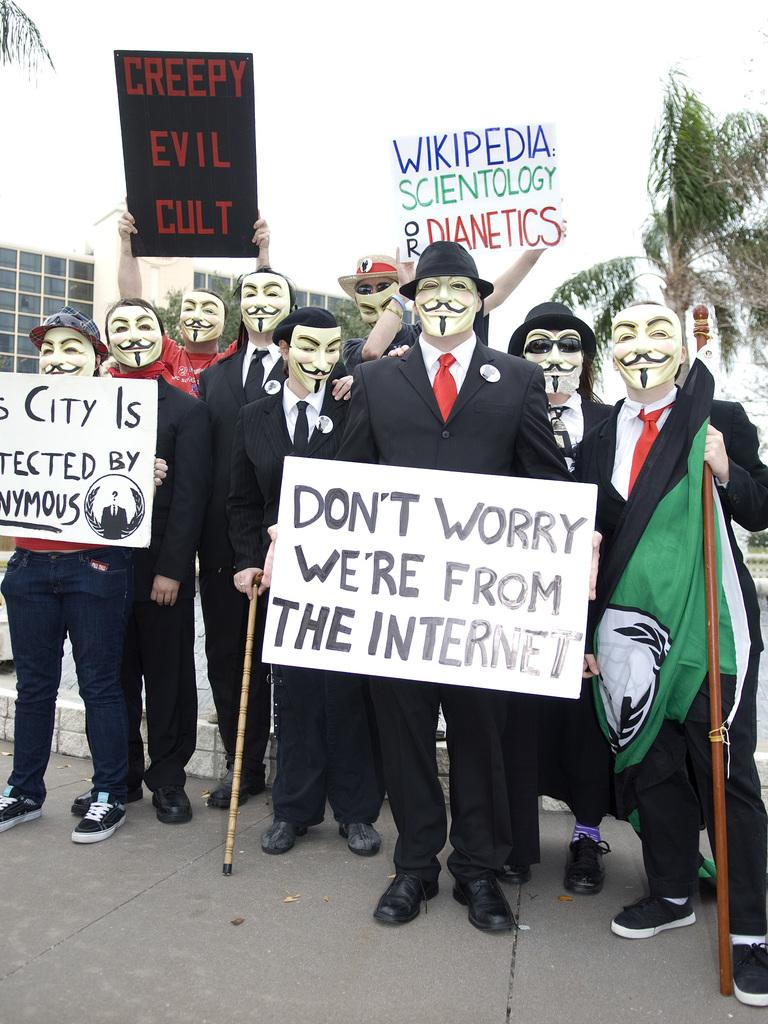How many people are in the image? There is a group of people in the image. What are the people wearing? The people are wearing fancy dress. What are some people holding in the image? Some people are holding boards and sticks. What can be seen in the distance? There are trees, a building, and the sky visible in the background of the image. What type of nut is being used as a centerpiece on the table in the image? There is no nut or table present in the image; it features a group of people wearing fancy dress and holding boards and sticks. 